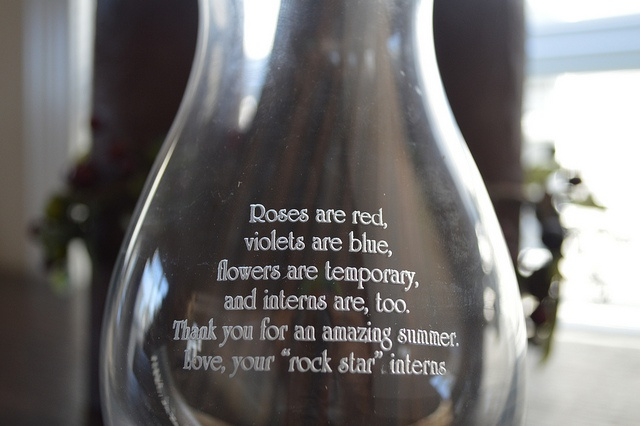Describe the objects in this image and their specific colors. I can see vase in gray, black, darkgray, and white tones and vase in black and gray tones in this image. 